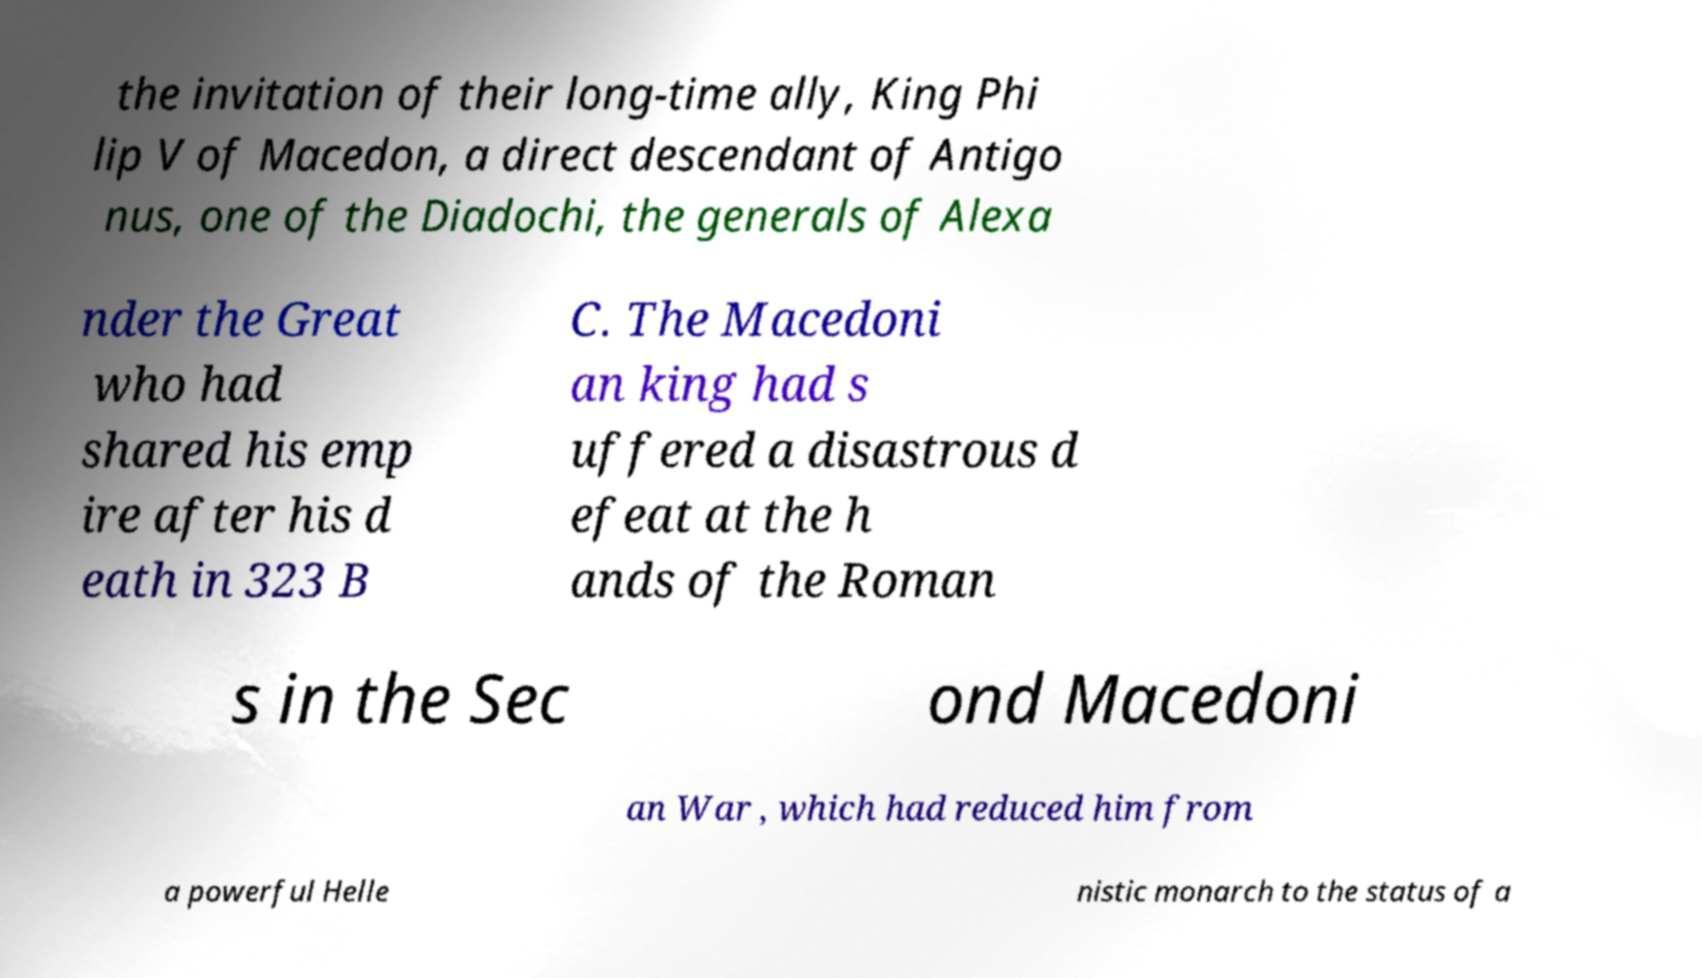Could you assist in decoding the text presented in this image and type it out clearly? the invitation of their long-time ally, King Phi lip V of Macedon, a direct descendant of Antigo nus, one of the Diadochi, the generals of Alexa nder the Great who had shared his emp ire after his d eath in 323 B C. The Macedoni an king had s uffered a disastrous d efeat at the h ands of the Roman s in the Sec ond Macedoni an War , which had reduced him from a powerful Helle nistic monarch to the status of a 